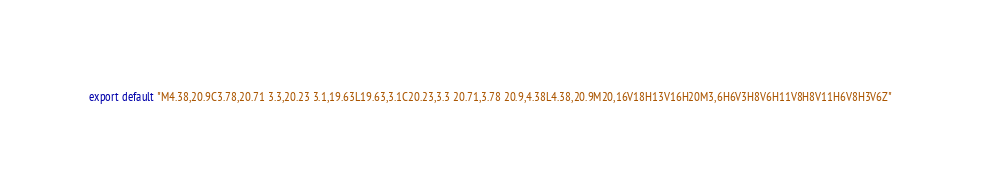<code> <loc_0><loc_0><loc_500><loc_500><_JavaScript_>export default "M4.38,20.9C3.78,20.71 3.3,20.23 3.1,19.63L19.63,3.1C20.23,3.3 20.71,3.78 20.9,4.38L4.38,20.9M20,16V18H13V16H20M3,6H6V3H8V6H11V8H8V11H6V8H3V6Z"</code> 